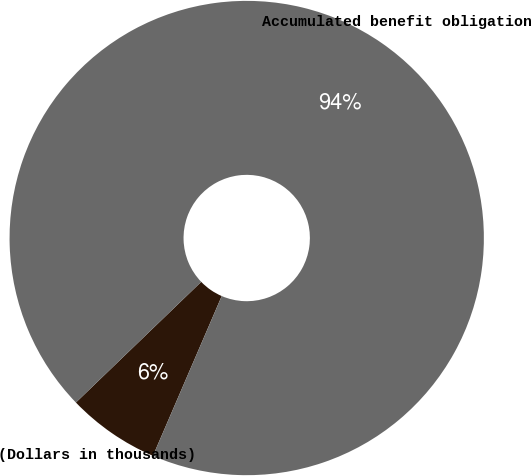Convert chart. <chart><loc_0><loc_0><loc_500><loc_500><pie_chart><fcel>(Dollars in thousands)<fcel>Accumulated benefit obligation<nl><fcel>6.33%<fcel>93.67%<nl></chart> 